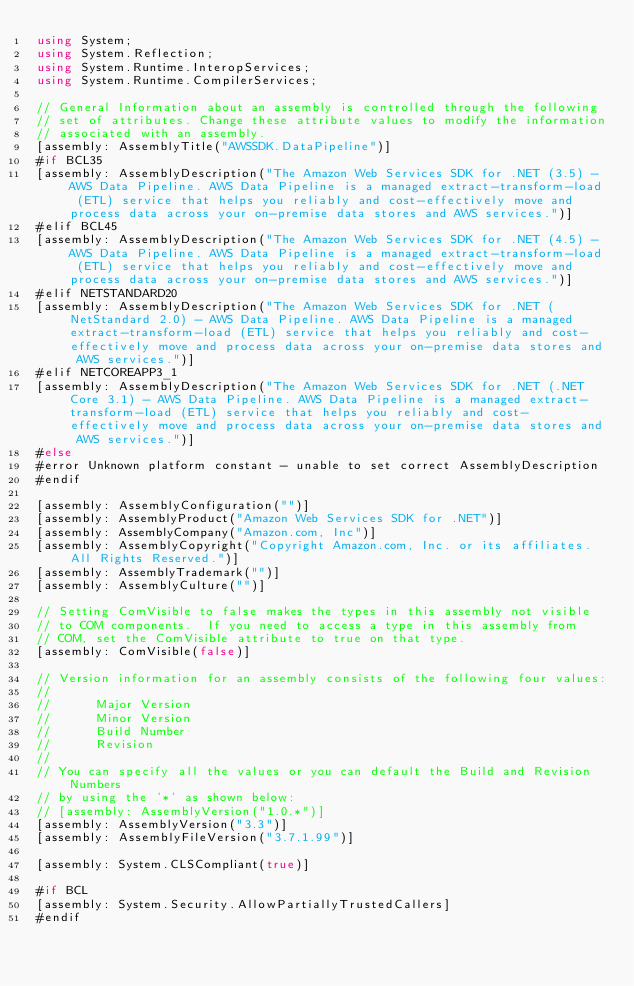Convert code to text. <code><loc_0><loc_0><loc_500><loc_500><_C#_>using System;
using System.Reflection;
using System.Runtime.InteropServices;
using System.Runtime.CompilerServices;

// General Information about an assembly is controlled through the following 
// set of attributes. Change these attribute values to modify the information
// associated with an assembly.
[assembly: AssemblyTitle("AWSSDK.DataPipeline")]
#if BCL35
[assembly: AssemblyDescription("The Amazon Web Services SDK for .NET (3.5) - AWS Data Pipeline. AWS Data Pipeline is a managed extract-transform-load (ETL) service that helps you reliably and cost-effectively move and process data across your on-premise data stores and AWS services.")]
#elif BCL45
[assembly: AssemblyDescription("The Amazon Web Services SDK for .NET (4.5) - AWS Data Pipeline. AWS Data Pipeline is a managed extract-transform-load (ETL) service that helps you reliably and cost-effectively move and process data across your on-premise data stores and AWS services.")]
#elif NETSTANDARD20
[assembly: AssemblyDescription("The Amazon Web Services SDK for .NET (NetStandard 2.0) - AWS Data Pipeline. AWS Data Pipeline is a managed extract-transform-load (ETL) service that helps you reliably and cost-effectively move and process data across your on-premise data stores and AWS services.")]
#elif NETCOREAPP3_1
[assembly: AssemblyDescription("The Amazon Web Services SDK for .NET (.NET Core 3.1) - AWS Data Pipeline. AWS Data Pipeline is a managed extract-transform-load (ETL) service that helps you reliably and cost-effectively move and process data across your on-premise data stores and AWS services.")]
#else
#error Unknown platform constant - unable to set correct AssemblyDescription
#endif

[assembly: AssemblyConfiguration("")]
[assembly: AssemblyProduct("Amazon Web Services SDK for .NET")]
[assembly: AssemblyCompany("Amazon.com, Inc")]
[assembly: AssemblyCopyright("Copyright Amazon.com, Inc. or its affiliates. All Rights Reserved.")]
[assembly: AssemblyTrademark("")]
[assembly: AssemblyCulture("")]

// Setting ComVisible to false makes the types in this assembly not visible 
// to COM components.  If you need to access a type in this assembly from 
// COM, set the ComVisible attribute to true on that type.
[assembly: ComVisible(false)]

// Version information for an assembly consists of the following four values:
//
//      Major Version
//      Minor Version 
//      Build Number
//      Revision
//
// You can specify all the values or you can default the Build and Revision Numbers 
// by using the '*' as shown below:
// [assembly: AssemblyVersion("1.0.*")]
[assembly: AssemblyVersion("3.3")]
[assembly: AssemblyFileVersion("3.7.1.99")]

[assembly: System.CLSCompliant(true)]

#if BCL
[assembly: System.Security.AllowPartiallyTrustedCallers]
#endif</code> 